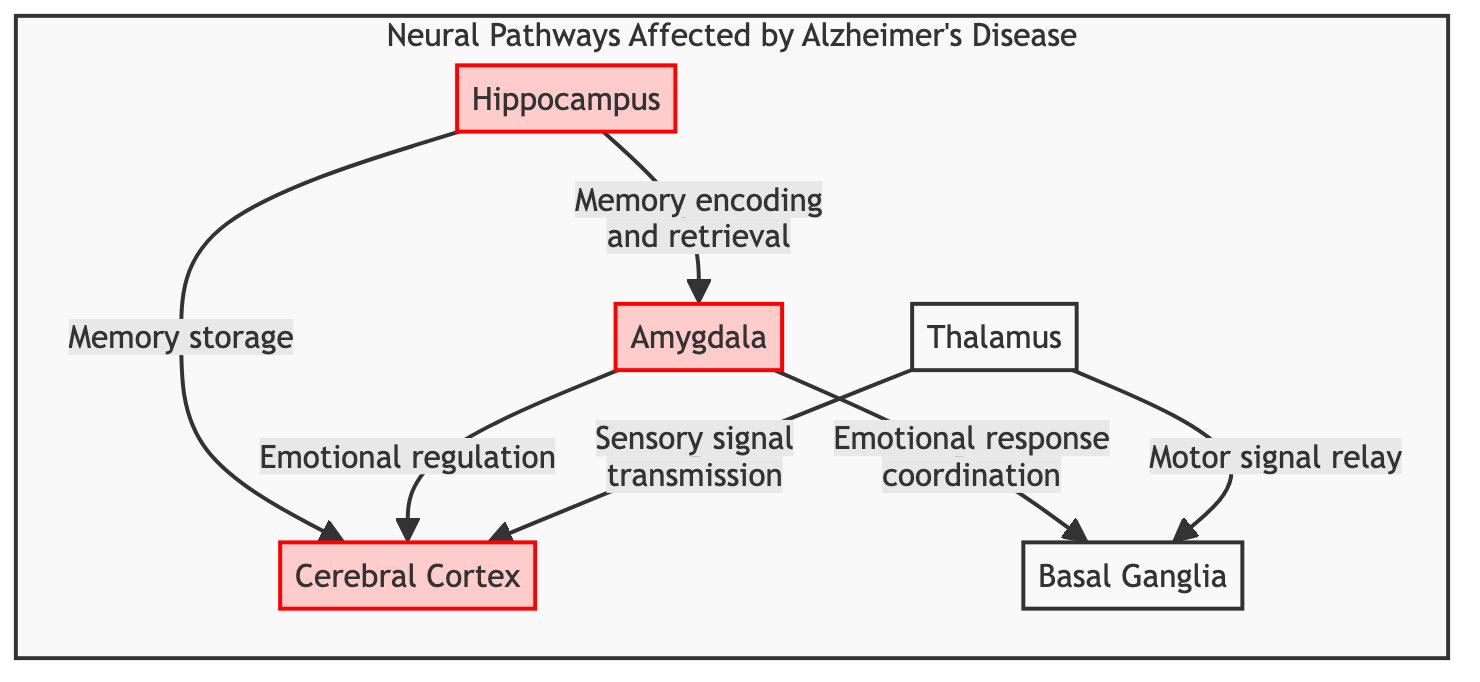What nodes are affected by Alzheimer's disease? The diagram clearly identifies nodes impacted by Alzheimer's disease, which are the Hippocampus, Cerebral Cortex, and Amygdala. They are marked with a distinctive red style indicating their affected status.
Answer: Hippocampus, Cerebral Cortex, Amygdala How many pathways lead out of the Hippocampus? By reviewing the diagram, there are two directed edges originating from the Hippocampus—one to the Cerebral Cortex and one to the Amygdala.
Answer: 2 What role does the Thalamus play in this diagram? The Thalamus transmits sensory signals to the Cerebral Cortex and relays motor signals to the Basal Ganglia, as indicated by its connection lines.
Answer: Sensory signal transmission, Motor signal relay Which node is responsible for emotional regulation? The connection from the Amygdala to the Cerebral Cortex indicates that the former is involved in emotional regulation as it coordinates emotional responses.
Answer: Amygdala What is the relationship between the Amygdala and the Basal Ganglia? The diagram shows a connection from the Amygdala to the Basal Ganglia, indicating that the Amygdala coordinates emotional responses with the Basal Ganglia.
Answer: Emotional response coordination Which node is not affected by Alzheimer's disease? The diagram distinguishes the Basal Ganglia and Thalamus from the affected nodes; they do not have the different red styling that indicates they are impacted.
Answer: Basal Ganglia, Thalamus How many affected nodes are there in total? Counting the affected nodes listed in the diagram reveals three specific nodes: the Hippocampus, Cerebral Cortex, and Amygdala.
Answer: 3 What function connects the Hippocampus to the Cerebral Cortex? The pathway from the Hippocampus to the Cerebral Cortex denotes a function of memory storage. This means the Hippocampus plays a key role in storing memories that are sent to the Cerebral Cortex.
Answer: Memory storage What type of diagram is this? This is a Biomedical Diagram, as it illustrates neural pathways and their relationships within the context of Alzheimer's disease.
Answer: Biomedical Diagram 